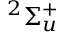<formula> <loc_0><loc_0><loc_500><loc_500>^ { 2 } \Sigma _ { u } ^ { + }</formula> 